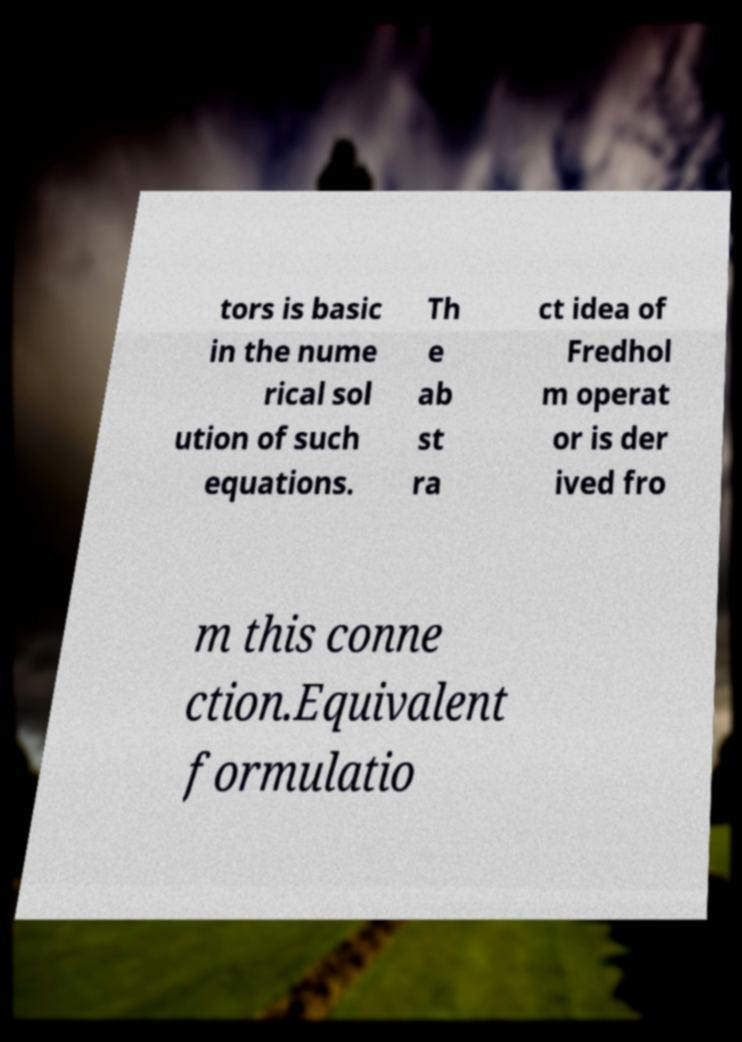Please identify and transcribe the text found in this image. tors is basic in the nume rical sol ution of such equations. Th e ab st ra ct idea of Fredhol m operat or is der ived fro m this conne ction.Equivalent formulatio 